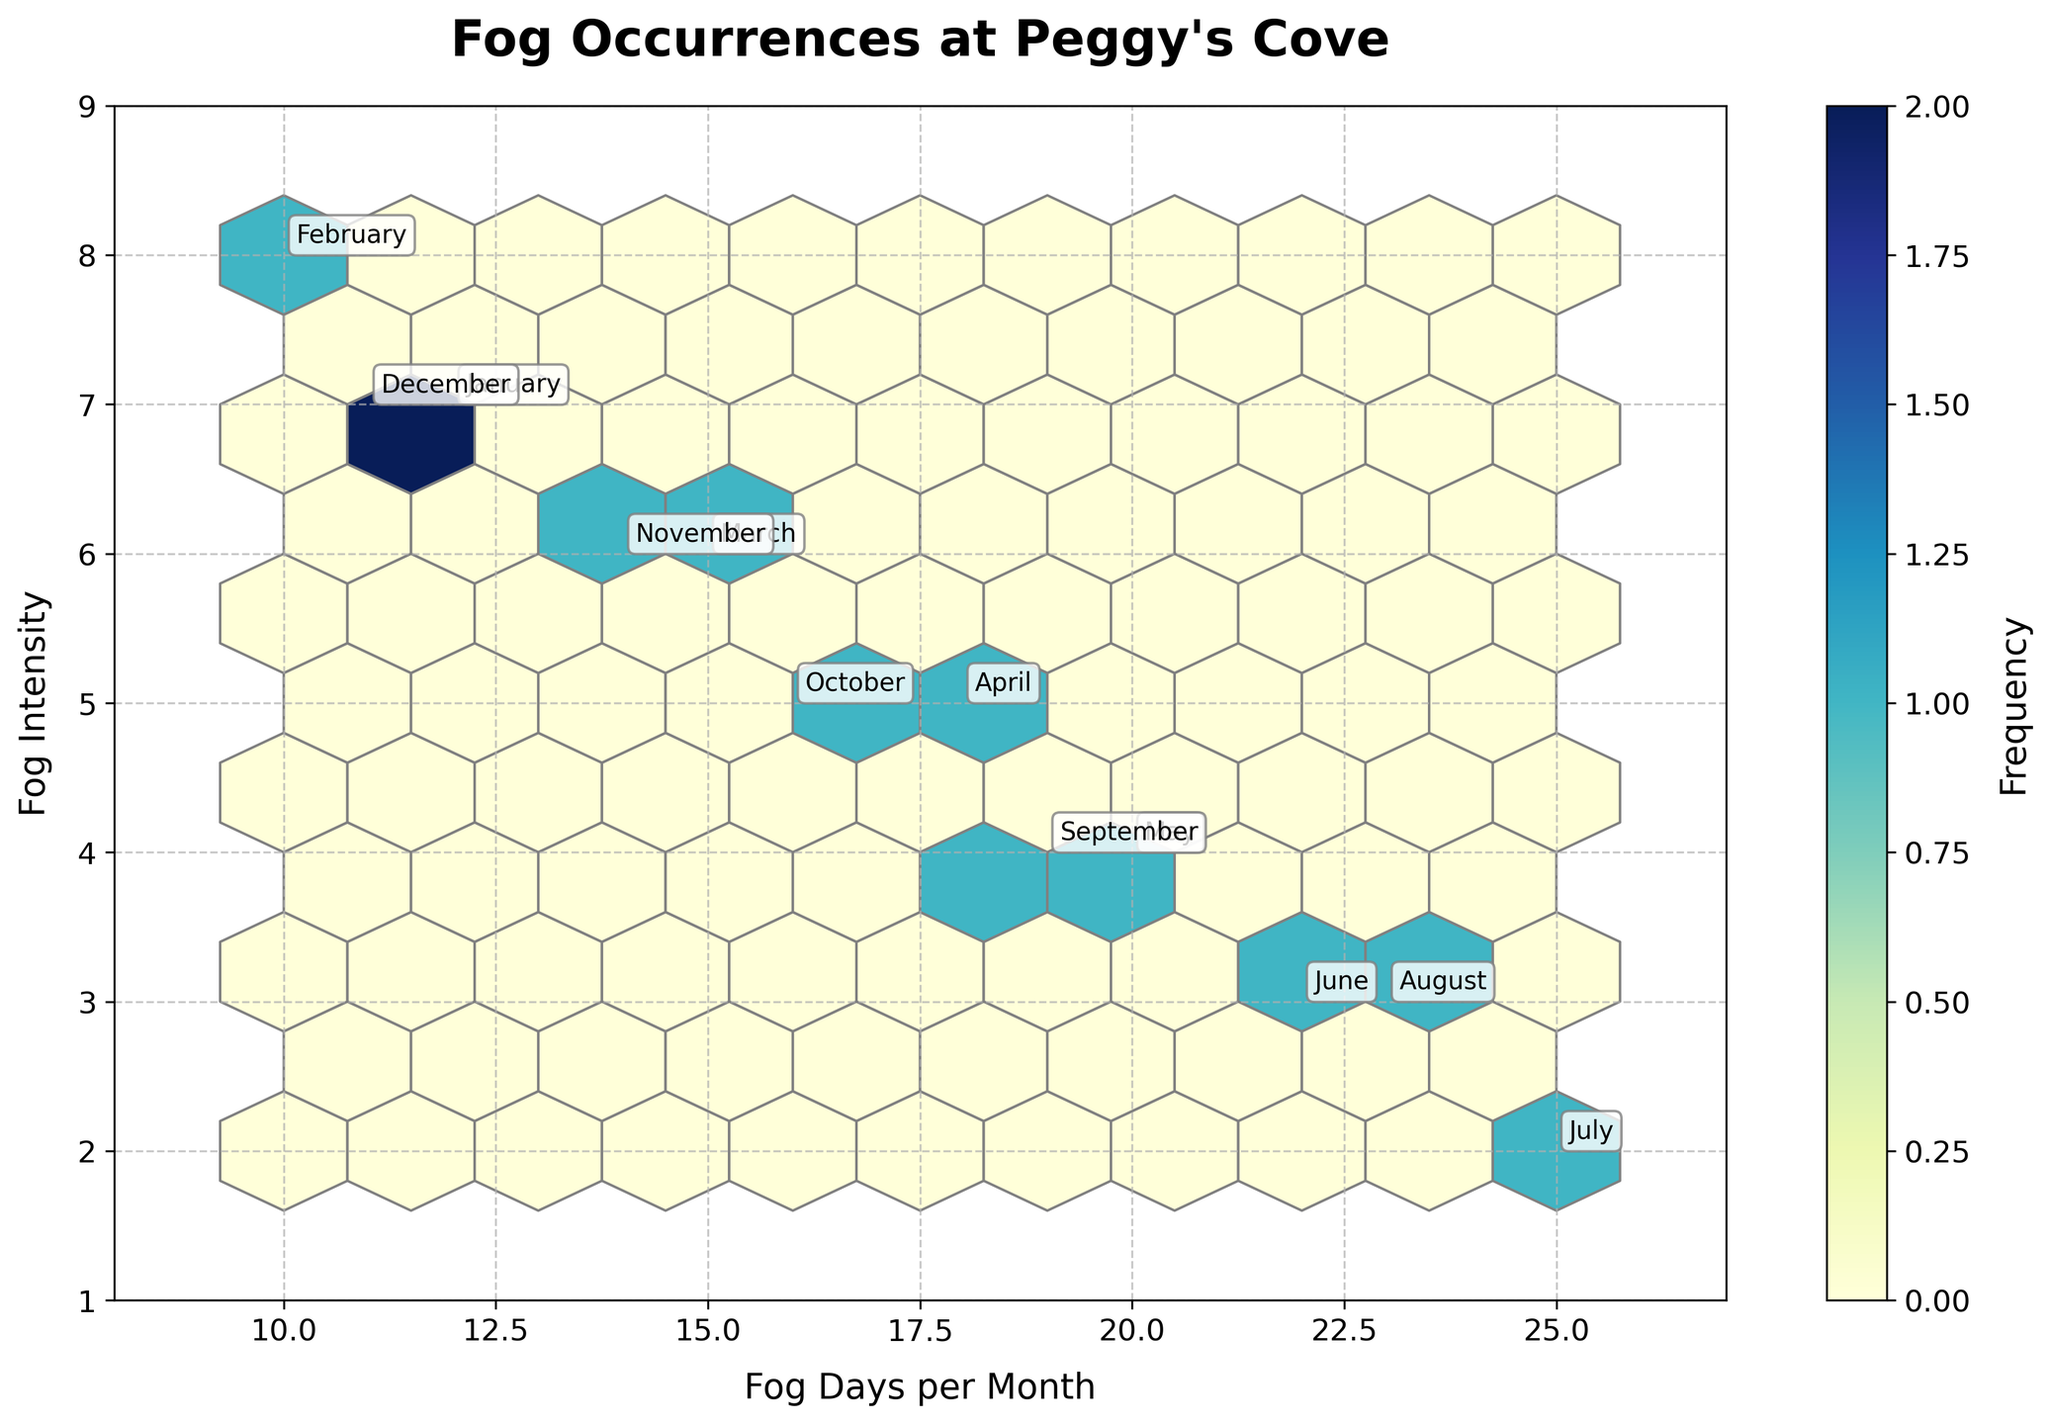What is the title of the plot? The title is usually located at the top of the plot, specifying the main focus of the data being visualized. In this case, it reads "Fog Occurrences at Peggy's Cove".
Answer: Fog Occurrences at Peggy's Cove How many hexagonal bins are present in the plot? Since the `gridsize` parameter is set to 10, which means the plot should have approximately 100 hexagonal bins. By visually counting them, it confirms this.
Answer: Approximately 100 Compare the fog intensity between January and December. By locating the bins representing January and December, we can see that their fog intensities are both 7. Thus, the fog intensity is equal for these two months.
Answer: Equal Which month has the minimum fog intensity? By looking at the lowest values on the y-axis labeled 'Fog Intensity', we see that July has the minimum fog intensity value of 2.
Answer: July How many fog days are there in the month with the second highest intensity? February has the highest fog intensity at 8. January and December both have the second highest intensity at 7. Checking 'Fog Days' for these two, which are both 12 each.
Answer: 12 Compare the frequency of fog occurrences in fall and spring. The color intensity in the spring months (March, April, May) appears lighter compared to the fall months (September, October, November), indicating fewer fog occurrences in spring overall.
Answer: Fall has more What is the average fog intensity for the summer months? Summer months are June, July, and August. Their fog intensities are 3, 2, and 3 respectively. The average is (3 + 2 + 3) / 3 = 8 / 3 = 2.67.
Answer: 2.67 